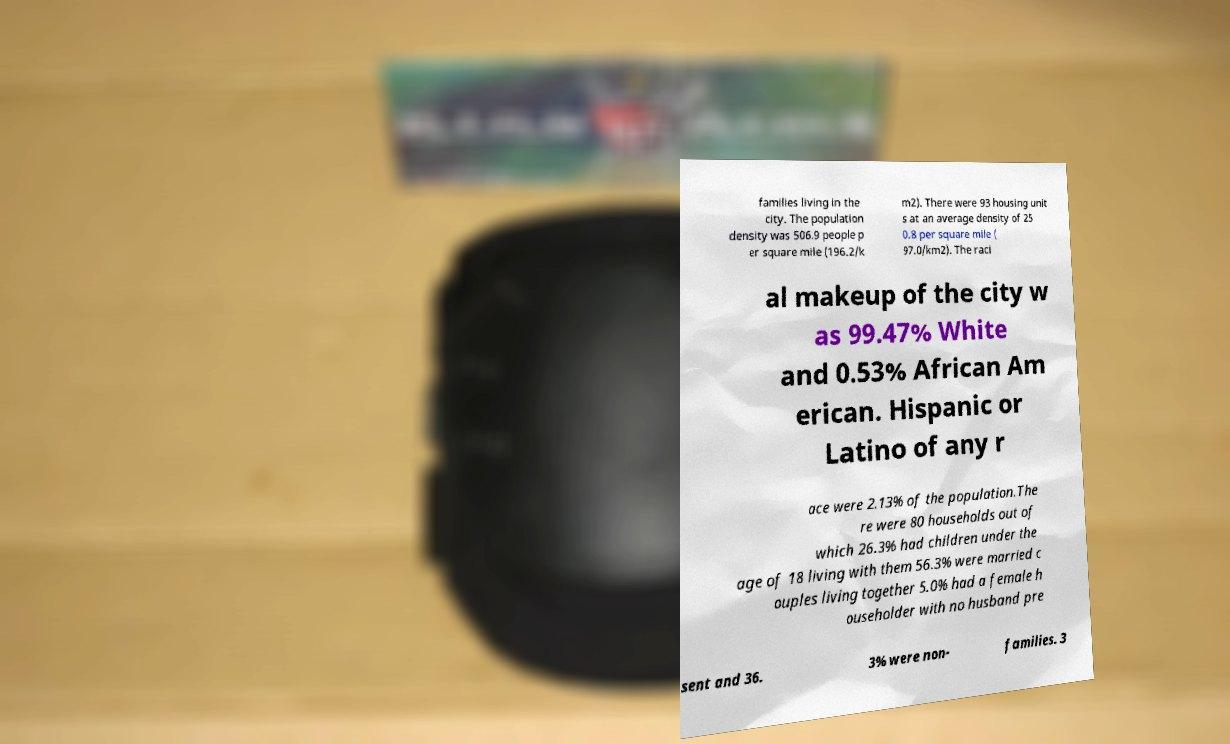What messages or text are displayed in this image? I need them in a readable, typed format. families living in the city. The population density was 506.9 people p er square mile (196.2/k m2). There were 93 housing unit s at an average density of 25 0.8 per square mile ( 97.0/km2). The raci al makeup of the city w as 99.47% White and 0.53% African Am erican. Hispanic or Latino of any r ace were 2.13% of the population.The re were 80 households out of which 26.3% had children under the age of 18 living with them 56.3% were married c ouples living together 5.0% had a female h ouseholder with no husband pre sent and 36. 3% were non- families. 3 